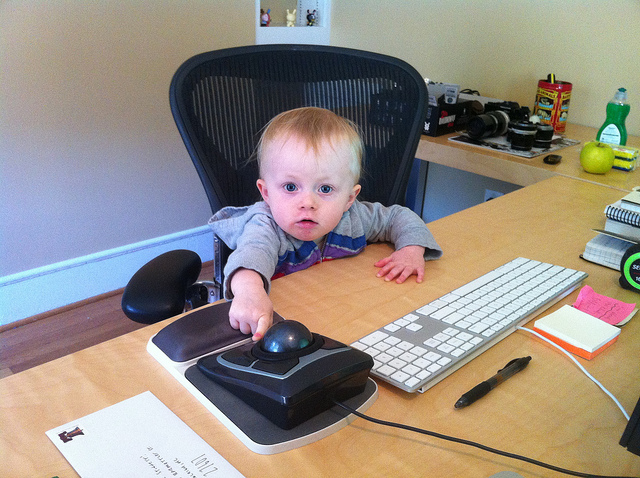Identify the text displayed in this image. 27607 